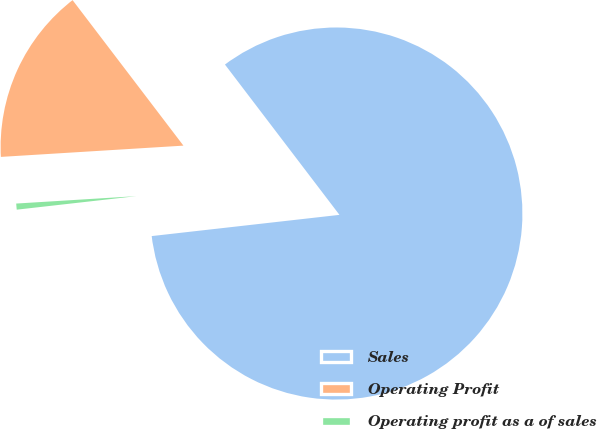Convert chart. <chart><loc_0><loc_0><loc_500><loc_500><pie_chart><fcel>Sales<fcel>Operating Profit<fcel>Operating profit as a of sales<nl><fcel>83.57%<fcel>15.62%<fcel>0.81%<nl></chart> 